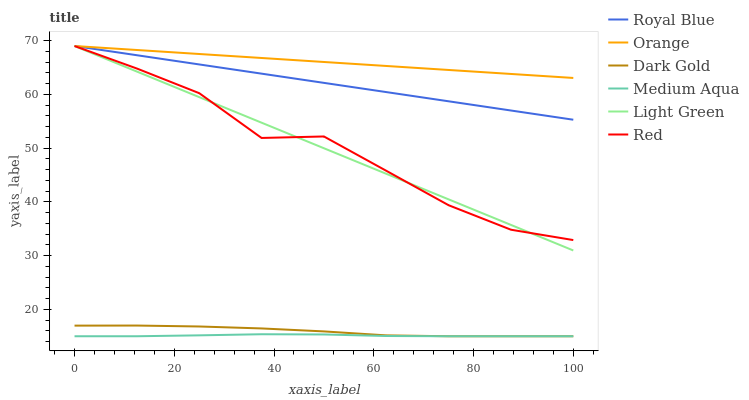Does Medium Aqua have the minimum area under the curve?
Answer yes or no. Yes. Does Orange have the maximum area under the curve?
Answer yes or no. Yes. Does Royal Blue have the minimum area under the curve?
Answer yes or no. No. Does Royal Blue have the maximum area under the curve?
Answer yes or no. No. Is Royal Blue the smoothest?
Answer yes or no. Yes. Is Red the roughest?
Answer yes or no. Yes. Is Medium Aqua the smoothest?
Answer yes or no. No. Is Medium Aqua the roughest?
Answer yes or no. No. Does Dark Gold have the lowest value?
Answer yes or no. Yes. Does Royal Blue have the lowest value?
Answer yes or no. No. Does Red have the highest value?
Answer yes or no. Yes. Does Medium Aqua have the highest value?
Answer yes or no. No. Is Medium Aqua less than Orange?
Answer yes or no. Yes. Is Royal Blue greater than Dark Gold?
Answer yes or no. Yes. Does Light Green intersect Red?
Answer yes or no. Yes. Is Light Green less than Red?
Answer yes or no. No. Is Light Green greater than Red?
Answer yes or no. No. Does Medium Aqua intersect Orange?
Answer yes or no. No. 